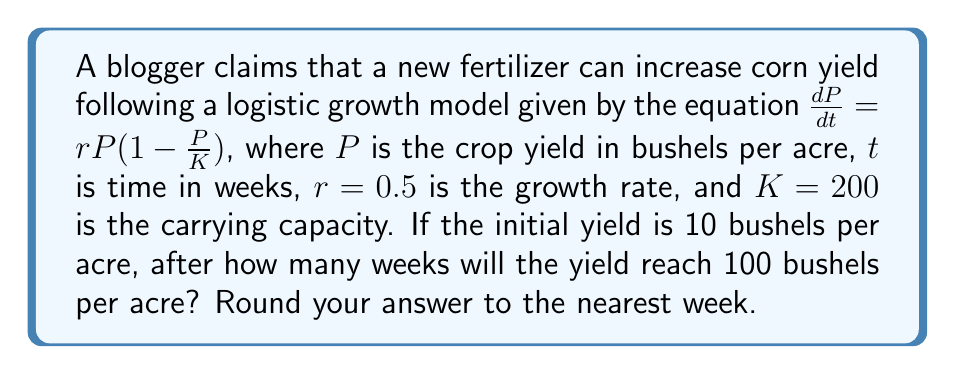Teach me how to tackle this problem. To solve this problem, we'll use the logistic growth model and follow these steps:

1) The general solution for the logistic growth model is:

   $P(t) = \frac{K}{1 + (\frac{K}{P_0} - 1)e^{-rt}}$

   where $P_0$ is the initial population (or yield in this case).

2) We're given:
   $K = 200$, $r = 0.5$, $P_0 = 10$, and we want to find $t$ when $P(t) = 100$

3) Substituting these values into the equation:

   $100 = \frac{200}{1 + (\frac{200}{10} - 1)e^{-0.5t}}$

4) Simplify:
   $100 = \frac{200}{1 + 19e^{-0.5t}}$

5) Multiply both sides by $(1 + 19e^{-0.5t})$:
   $100 + 1900e^{-0.5t} = 200$

6) Subtract 100 from both sides:
   $1900e^{-0.5t} = 100$

7) Divide both sides by 1900:
   $e^{-0.5t} = \frac{1}{19}$

8) Take the natural log of both sides:
   $-0.5t = \ln(\frac{1}{19})$

9) Divide both sides by -0.5:
   $t = -\frac{2}{1}\ln(\frac{1}{19}) = 2\ln(19)$

10) Calculate and round to the nearest week:
    $t \approx 5.88 \approx 6$ weeks
Answer: 6 weeks 